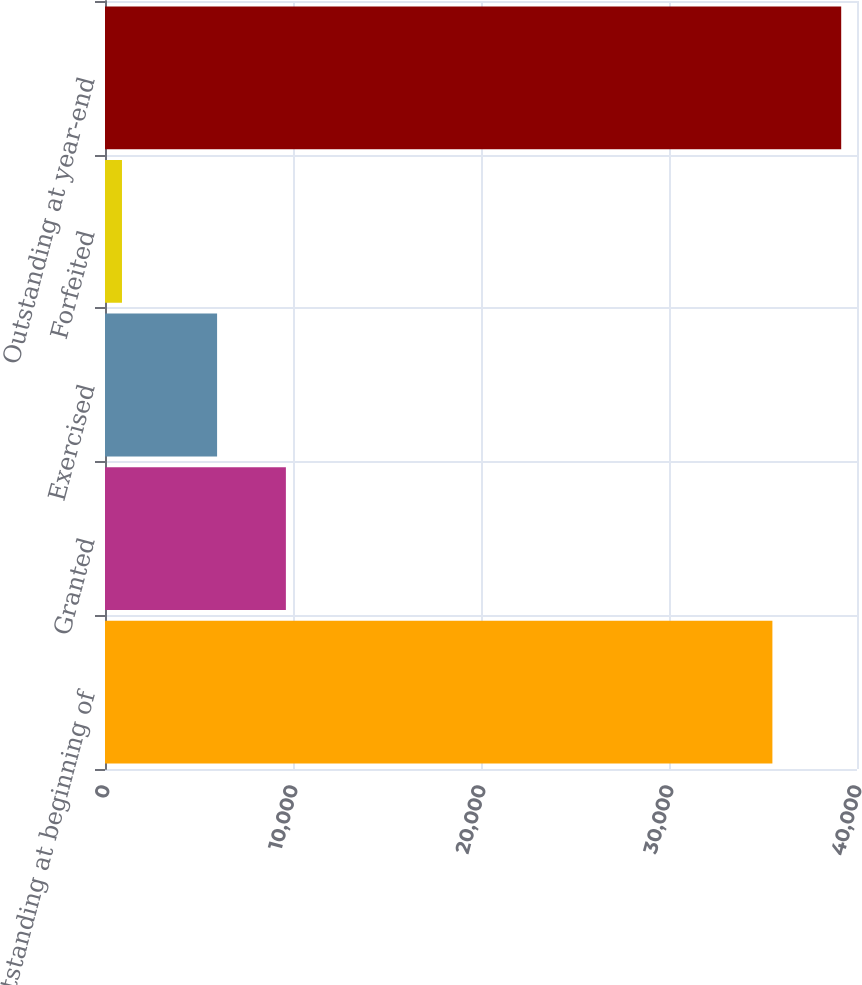<chart> <loc_0><loc_0><loc_500><loc_500><bar_chart><fcel>Outstanding at beginning of<fcel>Granted<fcel>Exercised<fcel>Forfeited<fcel>Outstanding at year-end<nl><fcel>35500<fcel>9621.6<fcel>5962<fcel>903<fcel>39159.6<nl></chart> 